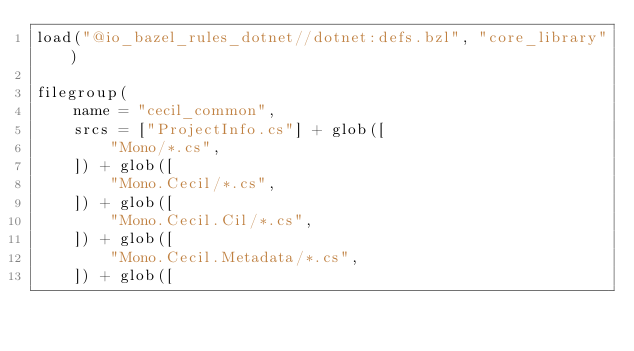<code> <loc_0><loc_0><loc_500><loc_500><_Python_>load("@io_bazel_rules_dotnet//dotnet:defs.bzl", "core_library")

filegroup(
    name = "cecil_common",
    srcs = ["ProjectInfo.cs"] + glob([
        "Mono/*.cs",
    ]) + glob([
        "Mono.Cecil/*.cs",
    ]) + glob([
        "Mono.Cecil.Cil/*.cs",
    ]) + glob([
        "Mono.Cecil.Metadata/*.cs",
    ]) + glob([</code> 